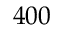Convert formula to latex. <formula><loc_0><loc_0><loc_500><loc_500>4 0 0</formula> 